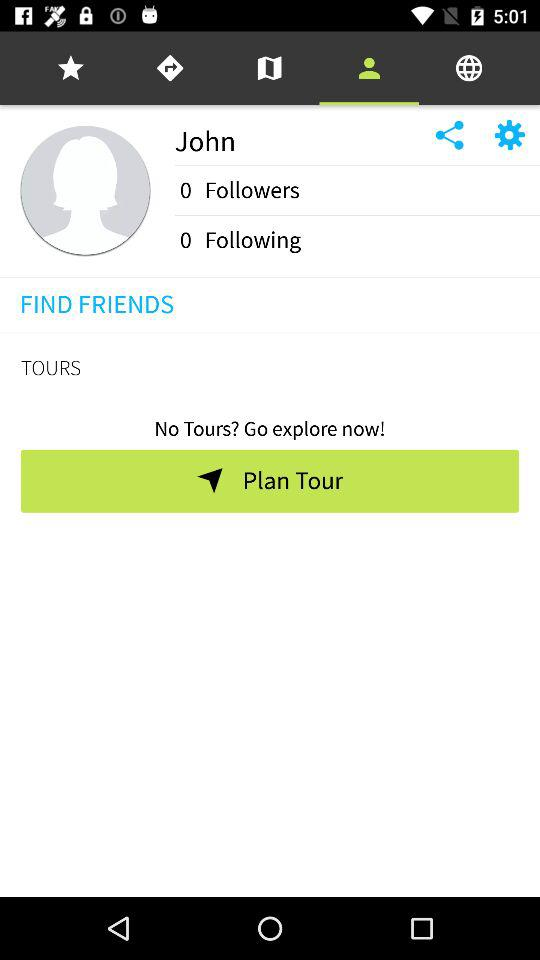What is the number of followers? The number of followers is 0. 